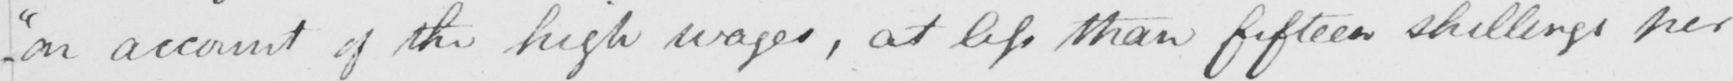What does this handwritten line say? "on account of the high wages, at less than fifteen shillings per 